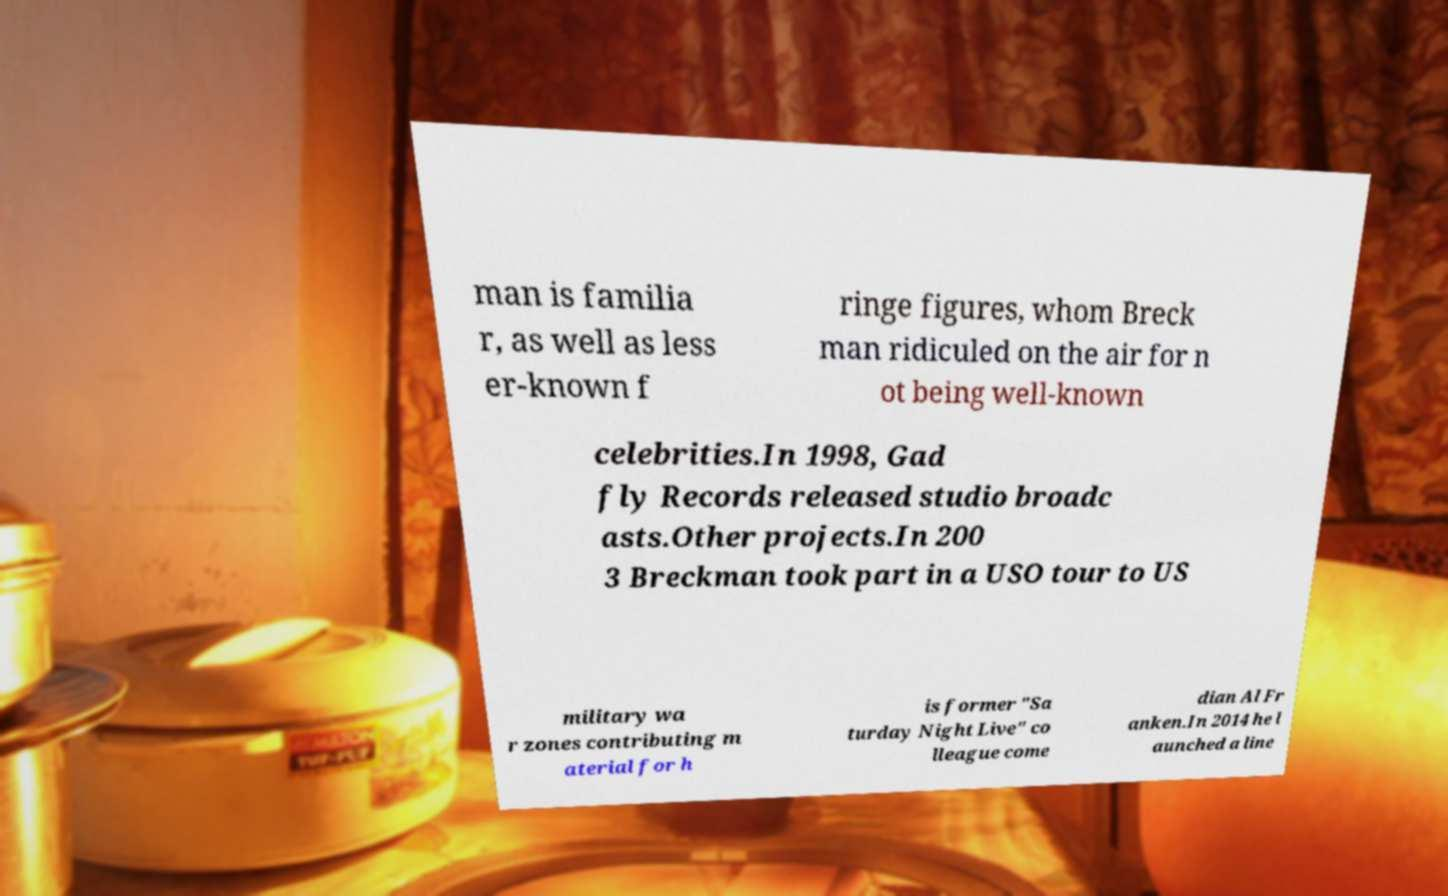Please read and relay the text visible in this image. What does it say? man is familia r, as well as less er-known f ringe figures, whom Breck man ridiculed on the air for n ot being well-known celebrities.In 1998, Gad fly Records released studio broadc asts.Other projects.In 200 3 Breckman took part in a USO tour to US military wa r zones contributing m aterial for h is former "Sa turday Night Live" co lleague come dian Al Fr anken.In 2014 he l aunched a line 